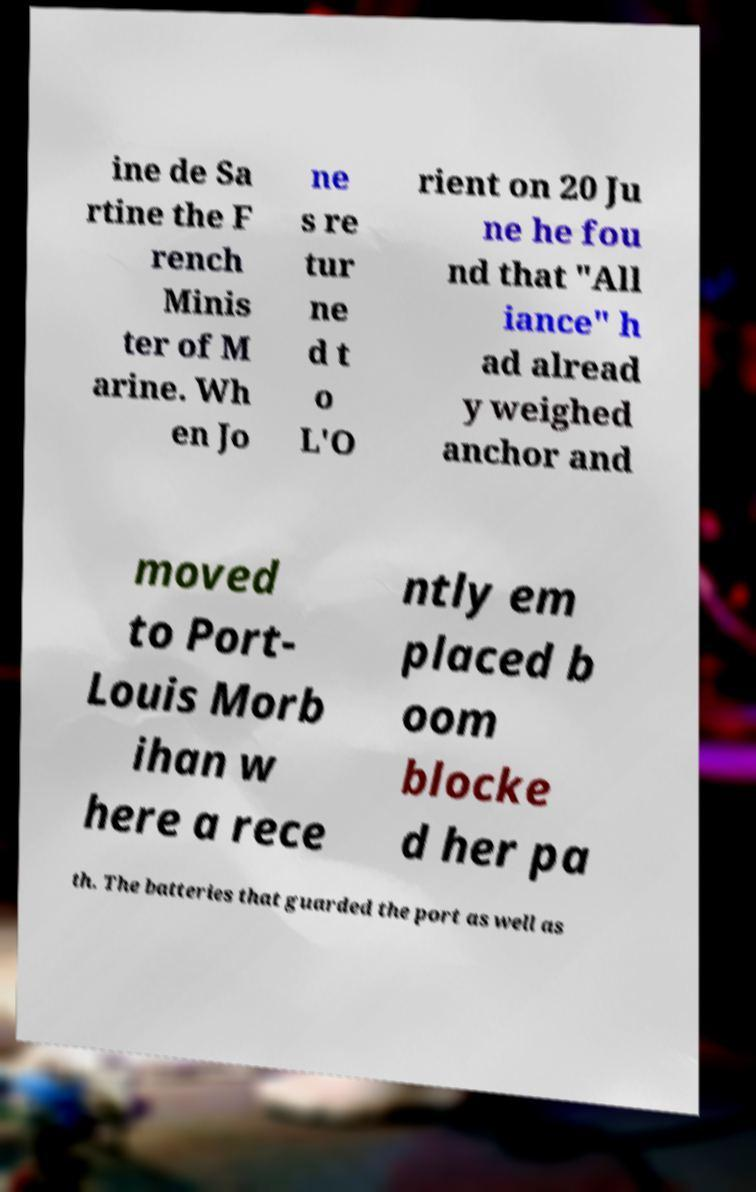Please identify and transcribe the text found in this image. ine de Sa rtine the F rench Minis ter of M arine. Wh en Jo ne s re tur ne d t o L'O rient on 20 Ju ne he fou nd that "All iance" h ad alread y weighed anchor and moved to Port- Louis Morb ihan w here a rece ntly em placed b oom blocke d her pa th. The batteries that guarded the port as well as 